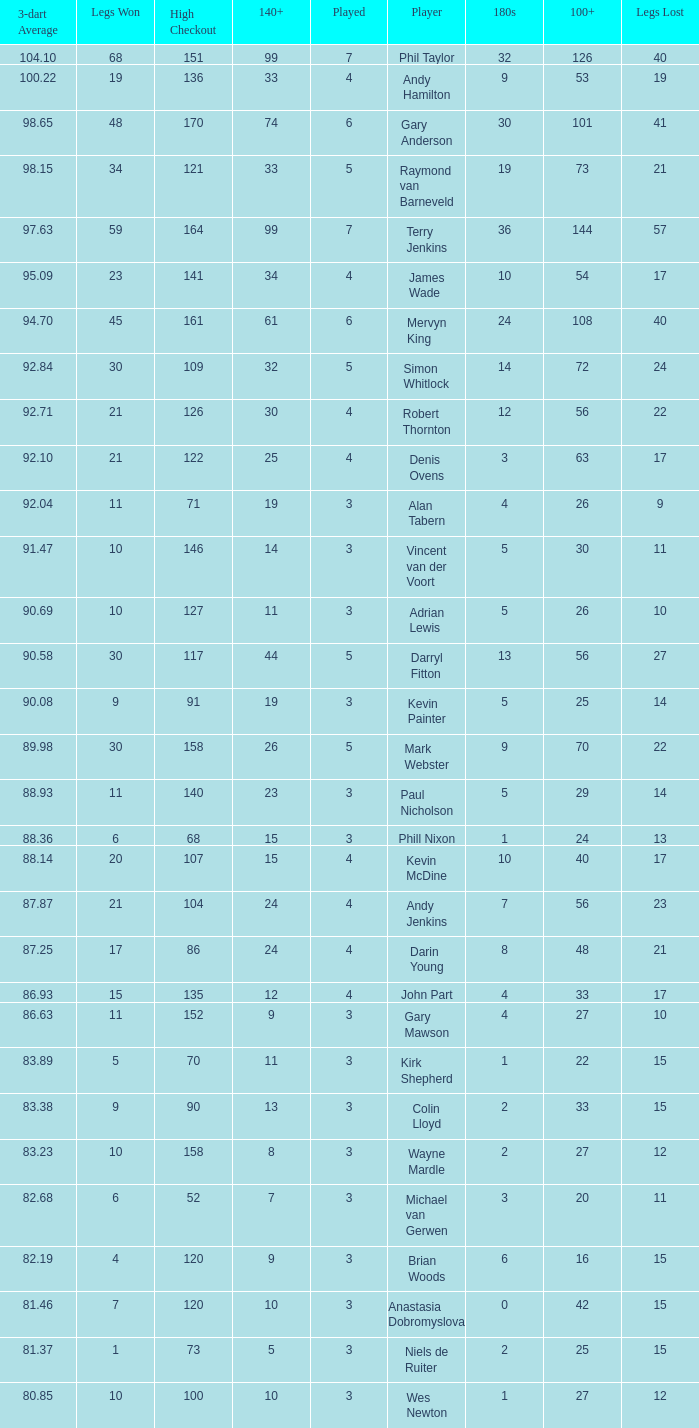Who is the player with 41 legs lost? Gary Anderson. 